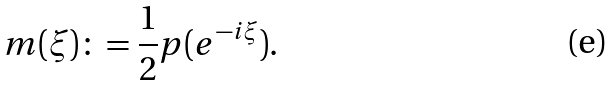<formula> <loc_0><loc_0><loc_500><loc_500>m ( \xi ) \colon = \frac { 1 } { 2 } p ( e ^ { - i \xi } ) .</formula> 